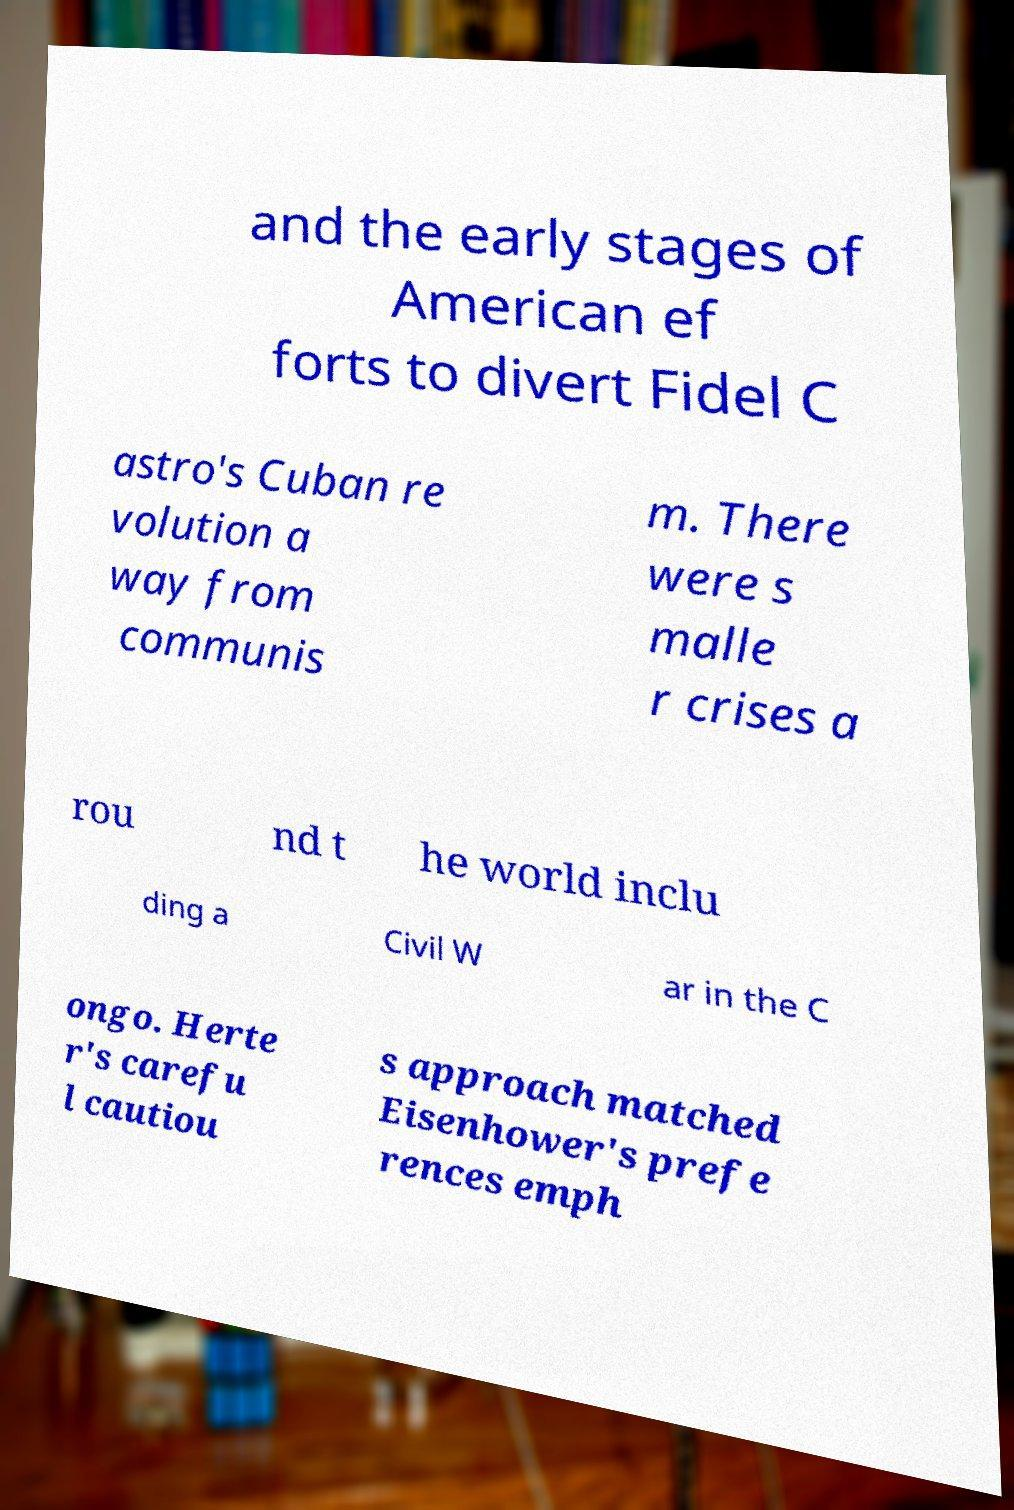What messages or text are displayed in this image? I need them in a readable, typed format. and the early stages of American ef forts to divert Fidel C astro's Cuban re volution a way from communis m. There were s malle r crises a rou nd t he world inclu ding a Civil W ar in the C ongo. Herte r's carefu l cautiou s approach matched Eisenhower's prefe rences emph 